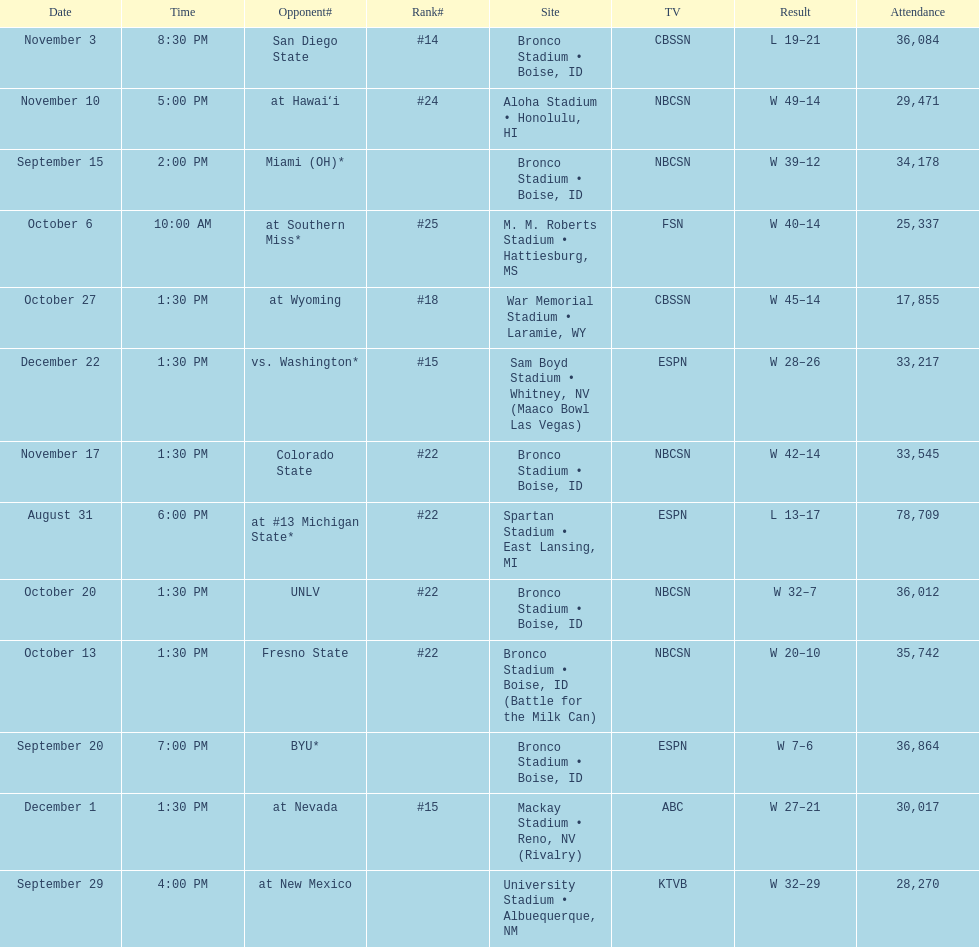After competing against unlv, who were the broncos' next opponents? Wyoming. 